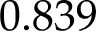<formula> <loc_0><loc_0><loc_500><loc_500>0 . 8 3 9</formula> 